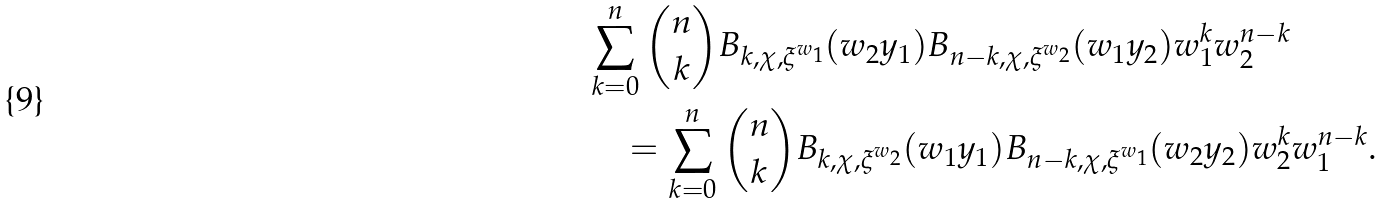<formula> <loc_0><loc_0><loc_500><loc_500>& \sum _ { k = 0 } ^ { n } \binom { n } { k } B _ { k , \chi , \xi ^ { w _ { 1 } } } ( w _ { 2 } y _ { 1 } ) B _ { n - k , \chi , \xi ^ { w _ { 2 } } } ( w _ { 1 } y _ { 2 } ) w _ { 1 } ^ { k } w _ { 2 } ^ { n - k } \\ & \quad = \sum _ { k = 0 } ^ { n } \binom { n } { k } B _ { k , \chi , \xi ^ { w _ { 2 } } } ( w _ { 1 } y _ { 1 } ) B _ { n - k , \chi , \xi ^ { w _ { 1 } } } ( w _ { 2 } y _ { 2 } ) w _ { 2 } ^ { k } w _ { 1 } ^ { n - k } .</formula> 